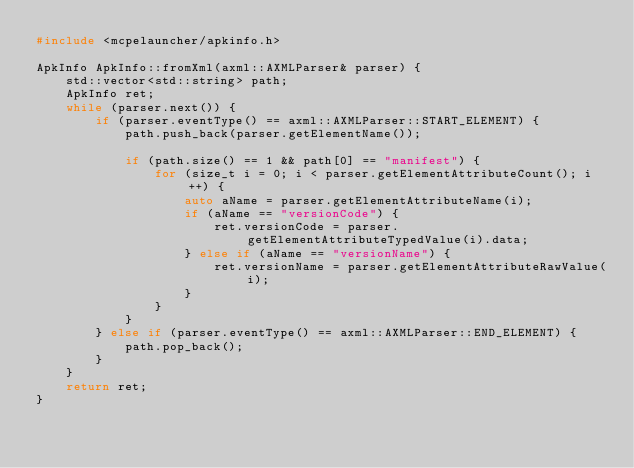Convert code to text. <code><loc_0><loc_0><loc_500><loc_500><_C++_>#include <mcpelauncher/apkinfo.h>

ApkInfo ApkInfo::fromXml(axml::AXMLParser& parser) {
    std::vector<std::string> path;
    ApkInfo ret;
    while (parser.next()) {
        if (parser.eventType() == axml::AXMLParser::START_ELEMENT) {
            path.push_back(parser.getElementName());

            if (path.size() == 1 && path[0] == "manifest") {
                for (size_t i = 0; i < parser.getElementAttributeCount(); i++) {
                    auto aName = parser.getElementAttributeName(i);
                    if (aName == "versionCode") {
                        ret.versionCode = parser.getElementAttributeTypedValue(i).data;
                    } else if (aName == "versionName") {
                        ret.versionName = parser.getElementAttributeRawValue(i);
                    }
                }
            }
        } else if (parser.eventType() == axml::AXMLParser::END_ELEMENT) {
            path.pop_back();
        }
    }
    return ret;
}</code> 